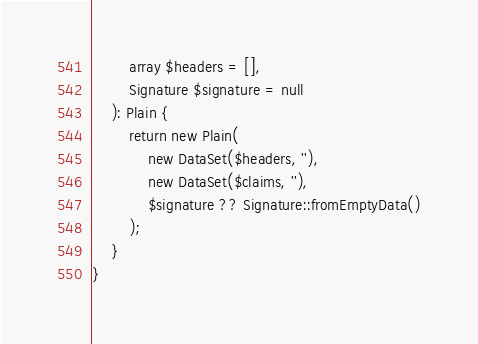Convert code to text. <code><loc_0><loc_0><loc_500><loc_500><_PHP_>        array $headers = [],
        Signature $signature = null
    ): Plain {
        return new Plain(
            new DataSet($headers, ''),
            new DataSet($claims, ''),
            $signature ?? Signature::fromEmptyData()
        );
    }
}
</code> 